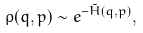Convert formula to latex. <formula><loc_0><loc_0><loc_500><loc_500>\rho ( q , p ) \sim e ^ { - \tilde { H } ( q , p ) } ,</formula> 